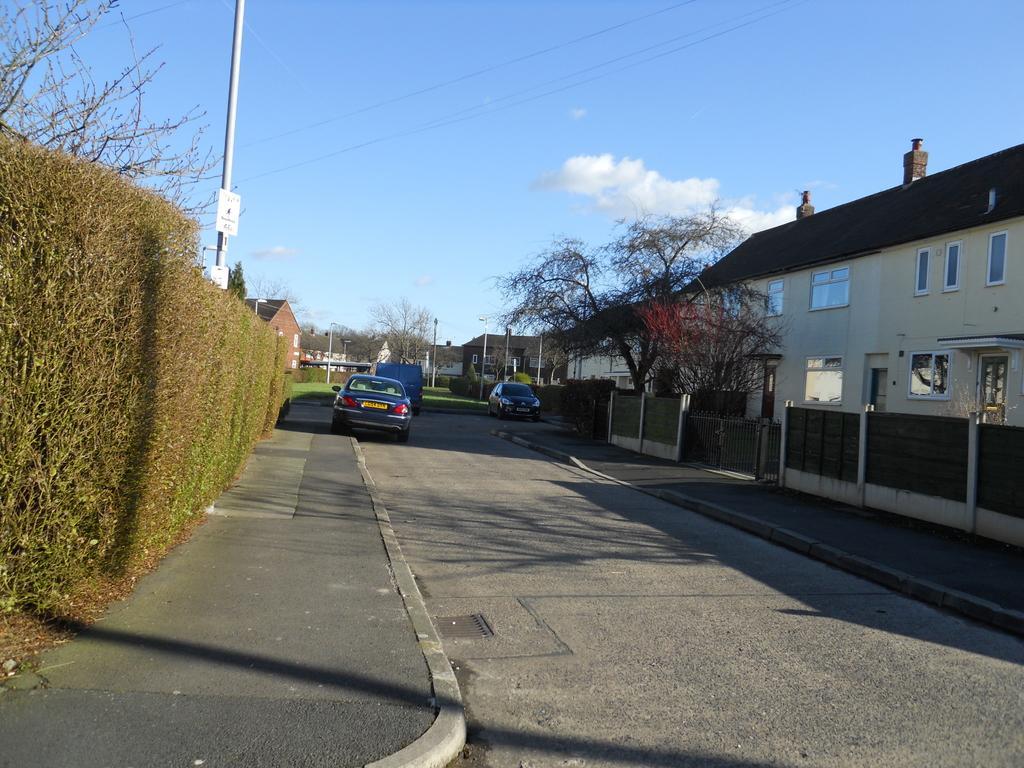Describe this image in one or two sentences. In this image in the center there are vehicles on the road. On the left side there is a plant and there are trees, there is a pole, building and on the right side there are buildings, trees, there is a gate, boundary wall and in the center there is grass on the ground and the sky is cloudy. 